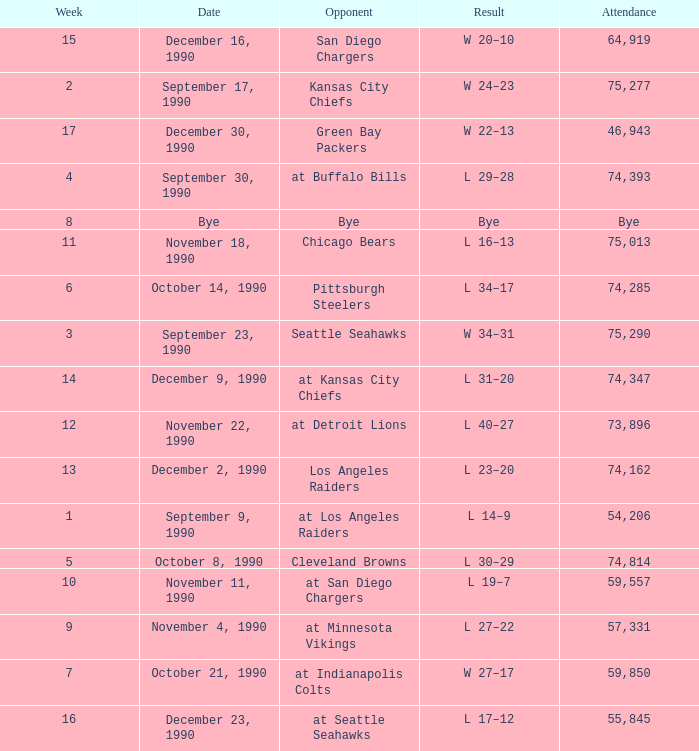What is the latest week with an attendance of 74,162? 13.0. 